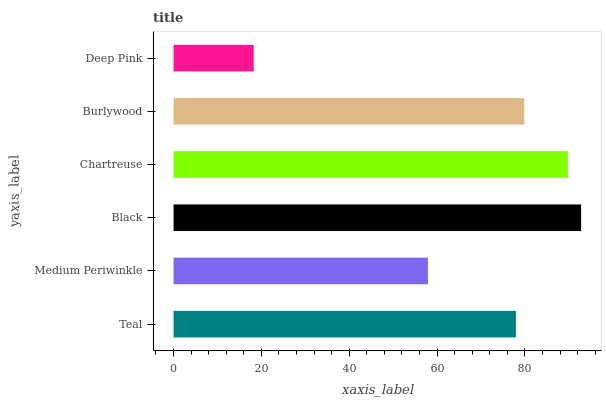Is Deep Pink the minimum?
Answer yes or no. Yes. Is Black the maximum?
Answer yes or no. Yes. Is Medium Periwinkle the minimum?
Answer yes or no. No. Is Medium Periwinkle the maximum?
Answer yes or no. No. Is Teal greater than Medium Periwinkle?
Answer yes or no. Yes. Is Medium Periwinkle less than Teal?
Answer yes or no. Yes. Is Medium Periwinkle greater than Teal?
Answer yes or no. No. Is Teal less than Medium Periwinkle?
Answer yes or no. No. Is Burlywood the high median?
Answer yes or no. Yes. Is Teal the low median?
Answer yes or no. Yes. Is Medium Periwinkle the high median?
Answer yes or no. No. Is Black the low median?
Answer yes or no. No. 